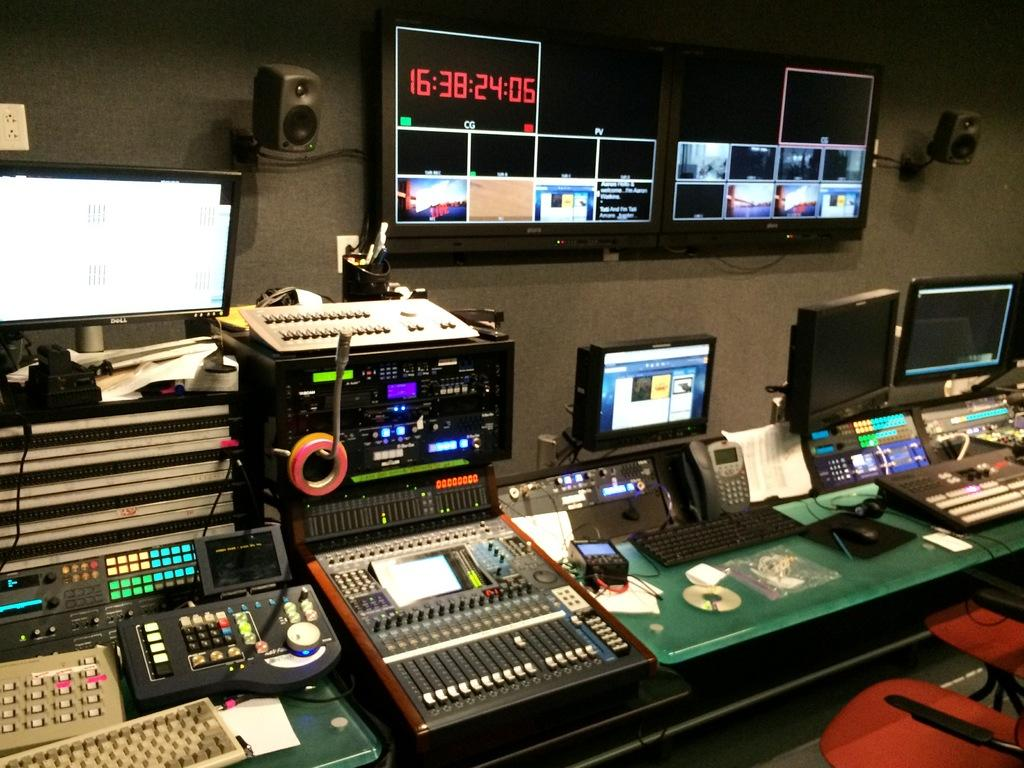<image>
Create a compact narrative representing the image presented. A counter with a lot of technical equipment including a sound-mixing board and monitors in front of two flat screens, one of which reads 16:38:24:06. 